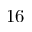<formula> <loc_0><loc_0><loc_500><loc_500>1 6</formula> 